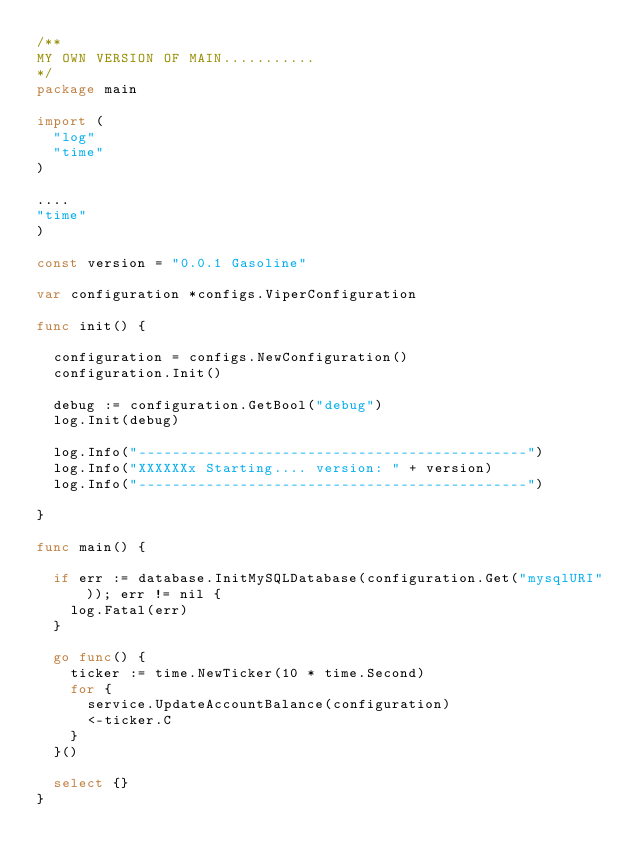Convert code to text. <code><loc_0><loc_0><loc_500><loc_500><_Go_>/**
MY OWN VERSION OF MAIN...........
*/
package main

import (
	"log"
	"time"
)

....
"time"
)

const version = "0.0.1 Gasoline"

var configuration *configs.ViperConfiguration

func init() {

	configuration = configs.NewConfiguration()
	configuration.Init()

	debug := configuration.GetBool("debug")
	log.Init(debug)

	log.Info("----------------------------------------------")
	log.Info("XXXXXXx Starting.... version: " + version)
	log.Info("----------------------------------------------")

}

func main() {

	if err := database.InitMySQLDatabase(configuration.Get("mysqlURI")); err != nil {
		log.Fatal(err)
	}

	go func() {
		ticker := time.NewTicker(10 * time.Second)
		for {
			service.UpdateAccountBalance(configuration)
			<-ticker.C
		}
	}()

	select {}
}
</code> 